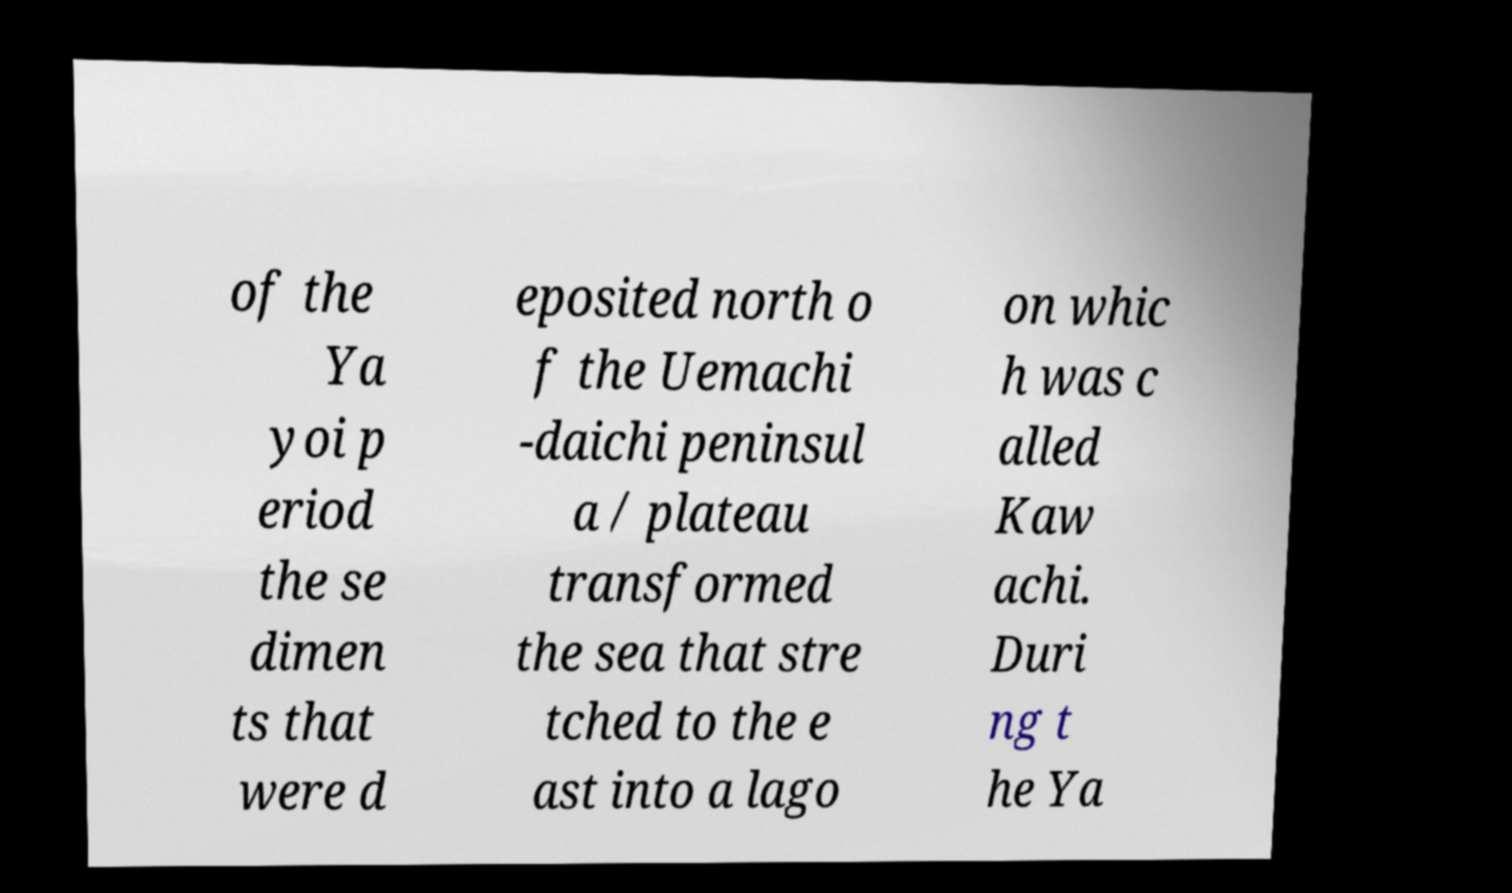What messages or text are displayed in this image? I need them in a readable, typed format. of the Ya yoi p eriod the se dimen ts that were d eposited north o f the Uemachi -daichi peninsul a / plateau transformed the sea that stre tched to the e ast into a lago on whic h was c alled Kaw achi. Duri ng t he Ya 